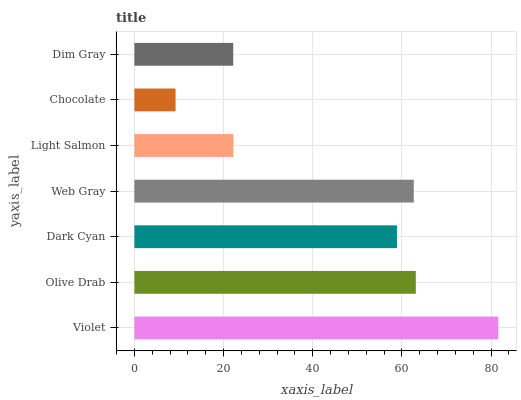Is Chocolate the minimum?
Answer yes or no. Yes. Is Violet the maximum?
Answer yes or no. Yes. Is Olive Drab the minimum?
Answer yes or no. No. Is Olive Drab the maximum?
Answer yes or no. No. Is Violet greater than Olive Drab?
Answer yes or no. Yes. Is Olive Drab less than Violet?
Answer yes or no. Yes. Is Olive Drab greater than Violet?
Answer yes or no. No. Is Violet less than Olive Drab?
Answer yes or no. No. Is Dark Cyan the high median?
Answer yes or no. Yes. Is Dark Cyan the low median?
Answer yes or no. Yes. Is Light Salmon the high median?
Answer yes or no. No. Is Violet the low median?
Answer yes or no. No. 